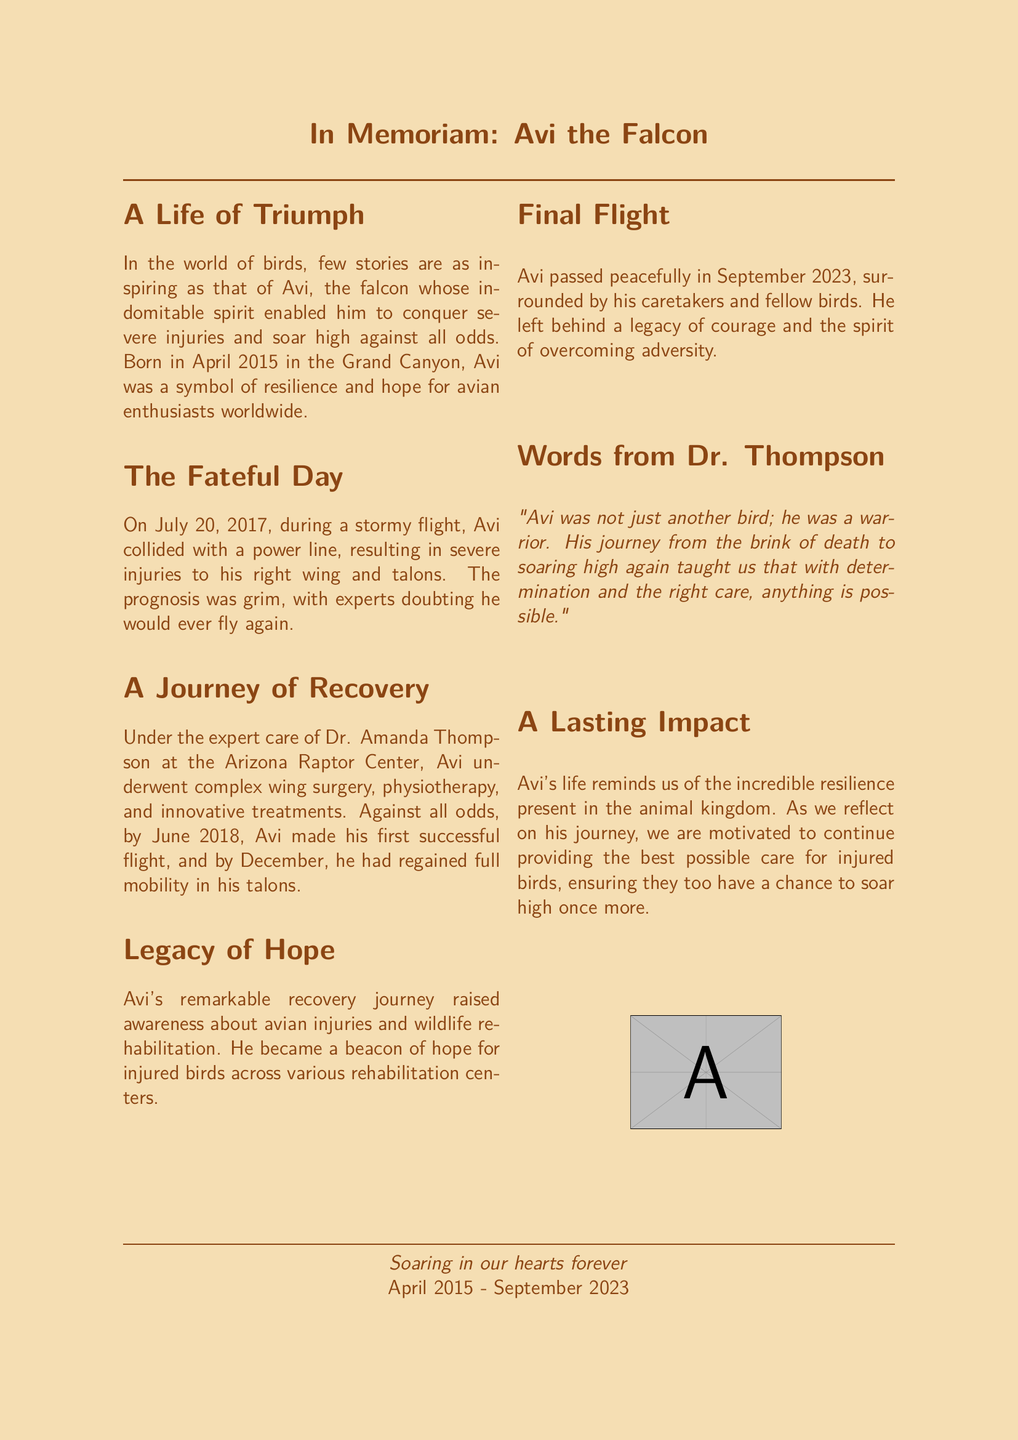What year was Avi born? The document states that Avi was born in April 2015.
Answer: April 2015 What caused Avi's severe injuries? The document mentions that Avi collided with a power line during a stormy flight.
Answer: Power line collision Who provided care for Avi during his recovery? According to the document, Dr. Amanda Thompson at the Arizona Raptor Center cared for Avi.
Answer: Dr. Amanda Thompson When did Avi make his first successful flight after recovery? The document notes that Avi made his first successful flight by June 2018.
Answer: June 2018 What was the attitude of experts regarding Avi's flying ability after his injuries? The document indicates that experts doubted he would ever fly again.
Answer: Doubted he would fly again What is the significance of Avi's recovery journey mentioned in the obituary? The document states that Avi's recovery raised awareness about avian injuries and wildlife rehabilitation.
Answer: Raised awareness In what month and year did Avi pass away? The document indicates that Avi passed away in September 2023.
Answer: September 2023 What phrase does Dr. Thompson use to describe Avi's spirit? The document quotes Dr. Thompson calling Avi a "warrior."
Answer: Warrior What does Avi's life symbolize for injured birds, as mentioned in the document? The document describes Avi as a beacon of hope for injured birds across various rehabilitation centers.
Answer: Beacon of hope 